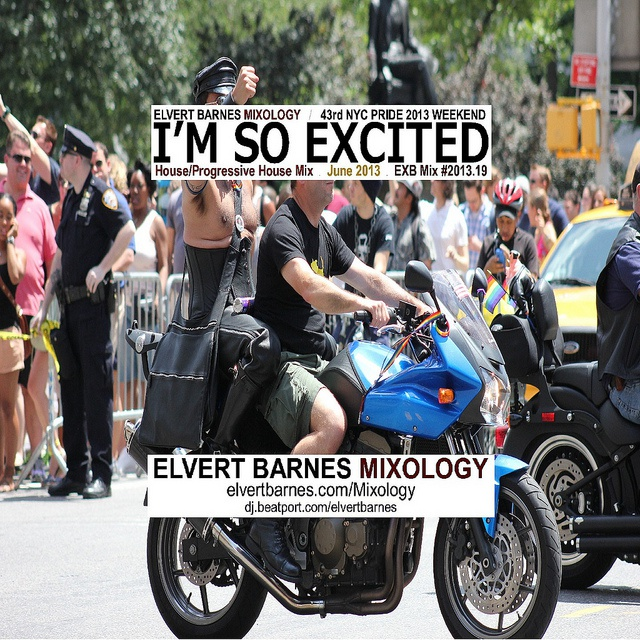Describe the objects in this image and their specific colors. I can see motorcycle in black, white, gray, and darkgray tones, people in black, white, and gray tones, motorcycle in black, gray, and darkgray tones, people in black, darkgray, and gray tones, and people in black, gray, and lightgray tones in this image. 